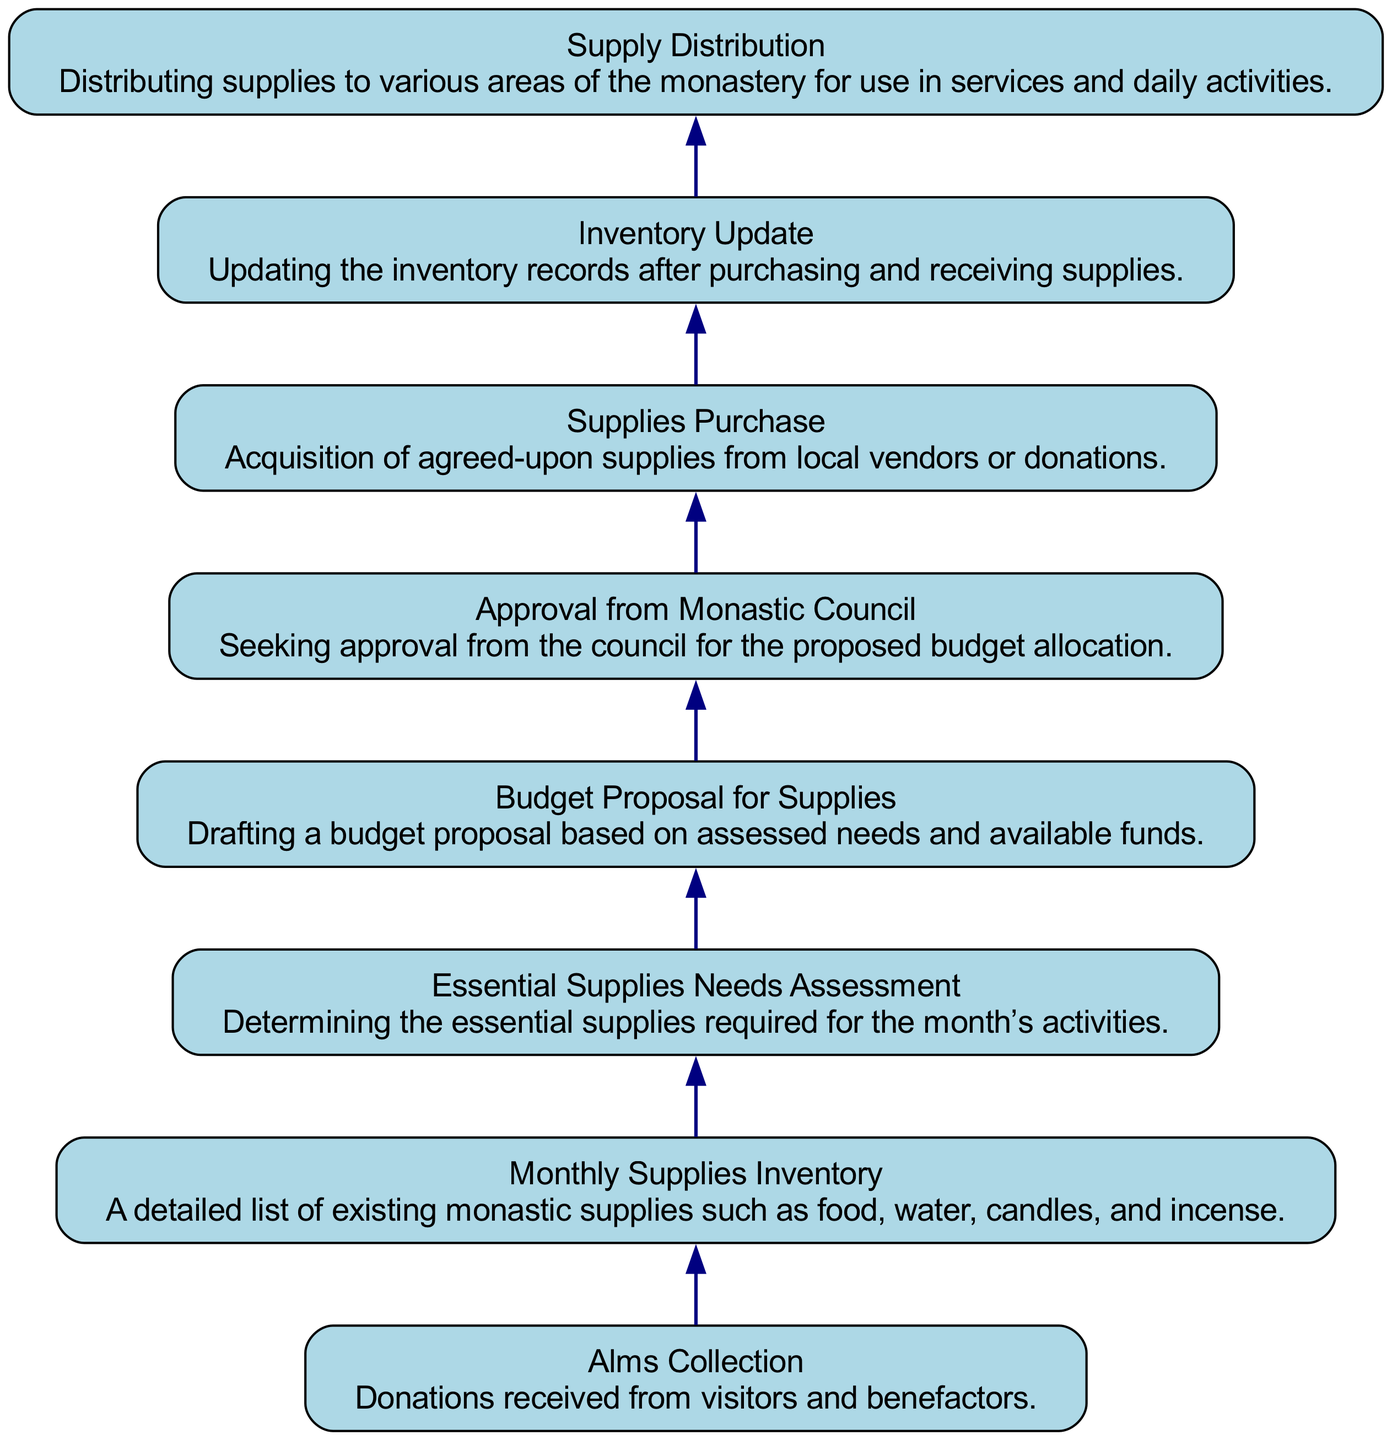What is the first node in the flow? The first node in the flow is labeled "Alms Collection," which represents the initial source of funds for the monastic supplies.
Answer: Alms Collection How many nodes are present in the diagram? There are a total of eight nodes present in the diagram, each representing a different step in the budget allocation process.
Answer: 8 Which node follows the "Essential Supplies Needs Assessment"? The node that follows "Essential Supplies Needs Assessment" is "Budget Proposal for Supplies," indicating that after assessing needs, a budget proposal is created.
Answer: Budget Proposal for Supplies What is the primary outcome of the final step in the flow? The final step "Supply Distribution" indicates the primary outcome is distributing supplies, highlighting the end goal of the process.
Answer: Supply Distribution What relationship exists between "Monthly Supplies Inventory" and "Essential Supplies Needs Assessment"? "Essential Supplies Needs Assessment" follows "Monthly Supplies Inventory," indicating that the current inventory informs the assessment of what is necessary for the upcoming month.
Answer: Needs assessment follows inventory How does the "Budget Proposal for Supplies" affect "Approval from Monastic Council"? The "Budget Proposal for Supplies" must be approved by the "Monastic Council," linking the proposal directly to the approval process. This shows that without a proposal, there will be no request for approval.
Answer: Proposal requires approval What is the purpose of the "Inventory Update" node? The purpose of the "Inventory Update" node is to ensure that records reflect newly purchased and received supplies, maintaining accurate tracking of supplies after distribution.
Answer: Updating records Which two nodes are directly connected to "Supplies Purchase"? The "Supplies Purchase" node is directly connected to "Approval from Monastic Council" (which confirms the purchase) and "Inventory Update" (which records the supplies after purchase).
Answer: Approval and Update 